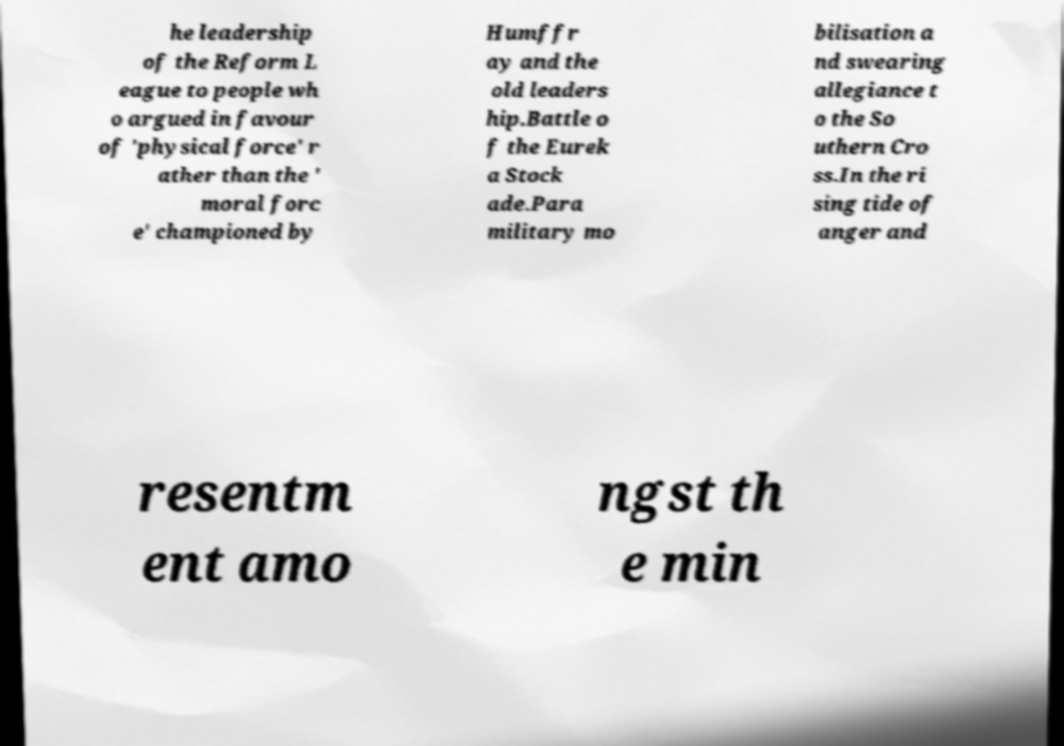Can you read and provide the text displayed in the image?This photo seems to have some interesting text. Can you extract and type it out for me? he leadership of the Reform L eague to people wh o argued in favour of 'physical force' r ather than the ' moral forc e' championed by Humffr ay and the old leaders hip.Battle o f the Eurek a Stock ade.Para military mo bilisation a nd swearing allegiance t o the So uthern Cro ss.In the ri sing tide of anger and resentm ent amo ngst th e min 